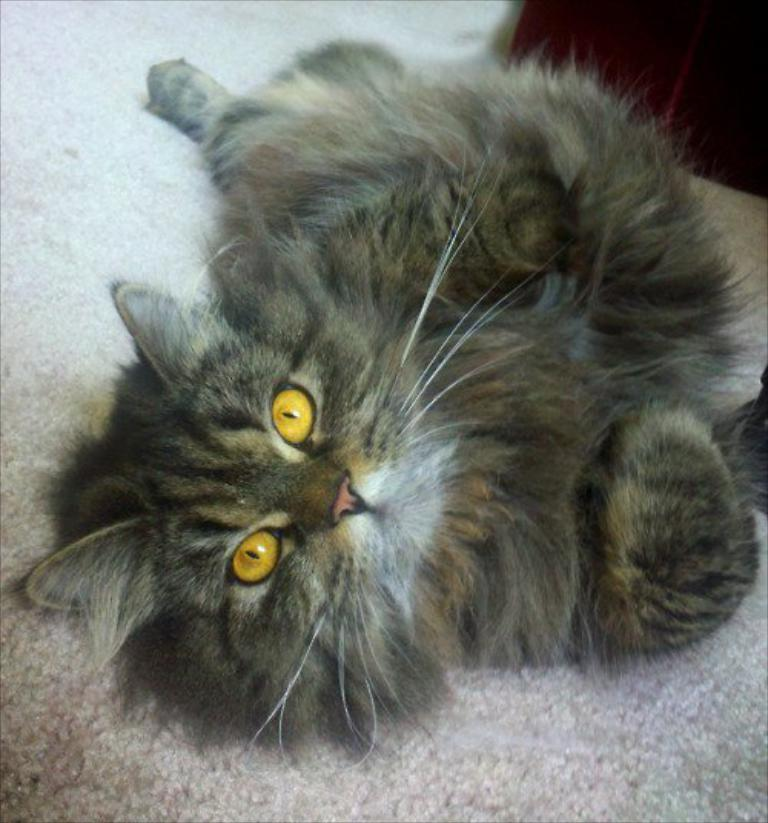What animal is present in the image? There is a cat in the image. Where is the cat located in the image? The cat is in the center of the image. What type of can does the cat use to smash in the image? There is no can or smashing activity present in the image; it features a cat in the center. 